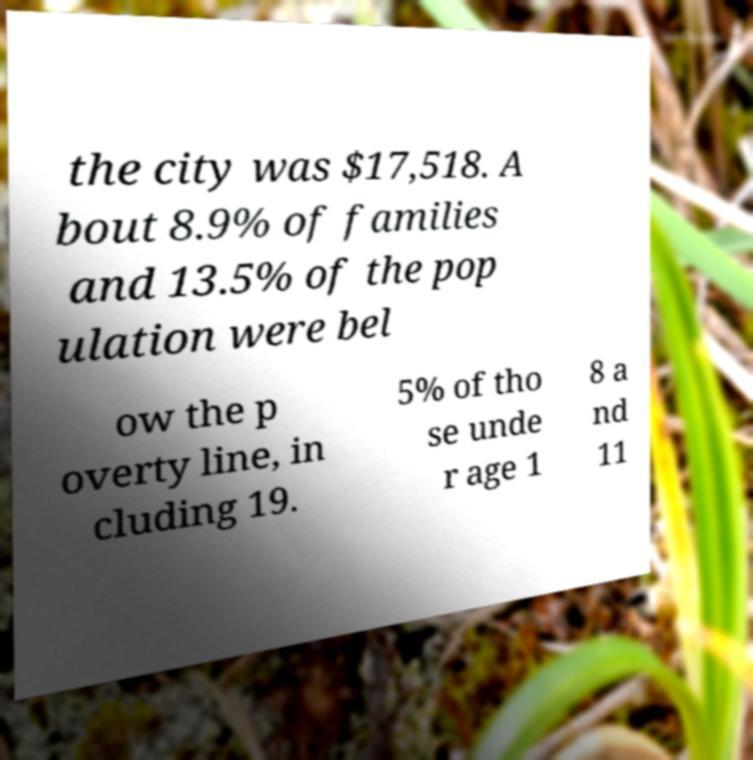I need the written content from this picture converted into text. Can you do that? the city was $17,518. A bout 8.9% of families and 13.5% of the pop ulation were bel ow the p overty line, in cluding 19. 5% of tho se unde r age 1 8 a nd 11 